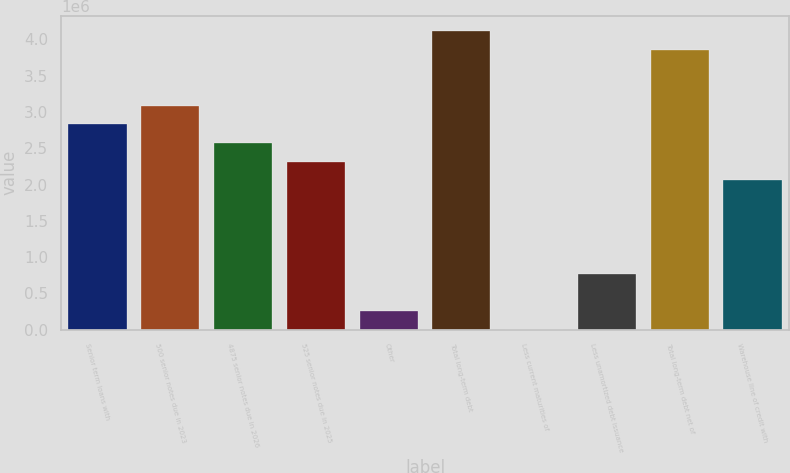Convert chart to OTSL. <chart><loc_0><loc_0><loc_500><loc_500><bar_chart><fcel>Senior term loans with<fcel>500 senior notes due in 2023<fcel>4875 senior notes due in 2026<fcel>525 senior notes due in 2025<fcel>Other<fcel>Total long-term debt<fcel>Less current maturities of<fcel>Less unamortized debt issuance<fcel>Total long-term debt net of<fcel>Warehouse line of credit with<nl><fcel>2.83173e+06<fcel>3.08916e+06<fcel>2.5743e+06<fcel>2.31687e+06<fcel>257440<fcel>4.11888e+06<fcel>11<fcel>772298<fcel>3.86145e+06<fcel>2.05944e+06<nl></chart> 